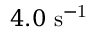<formula> <loc_0><loc_0><loc_500><loc_500>4 . 0 s ^ { - 1 }</formula> 